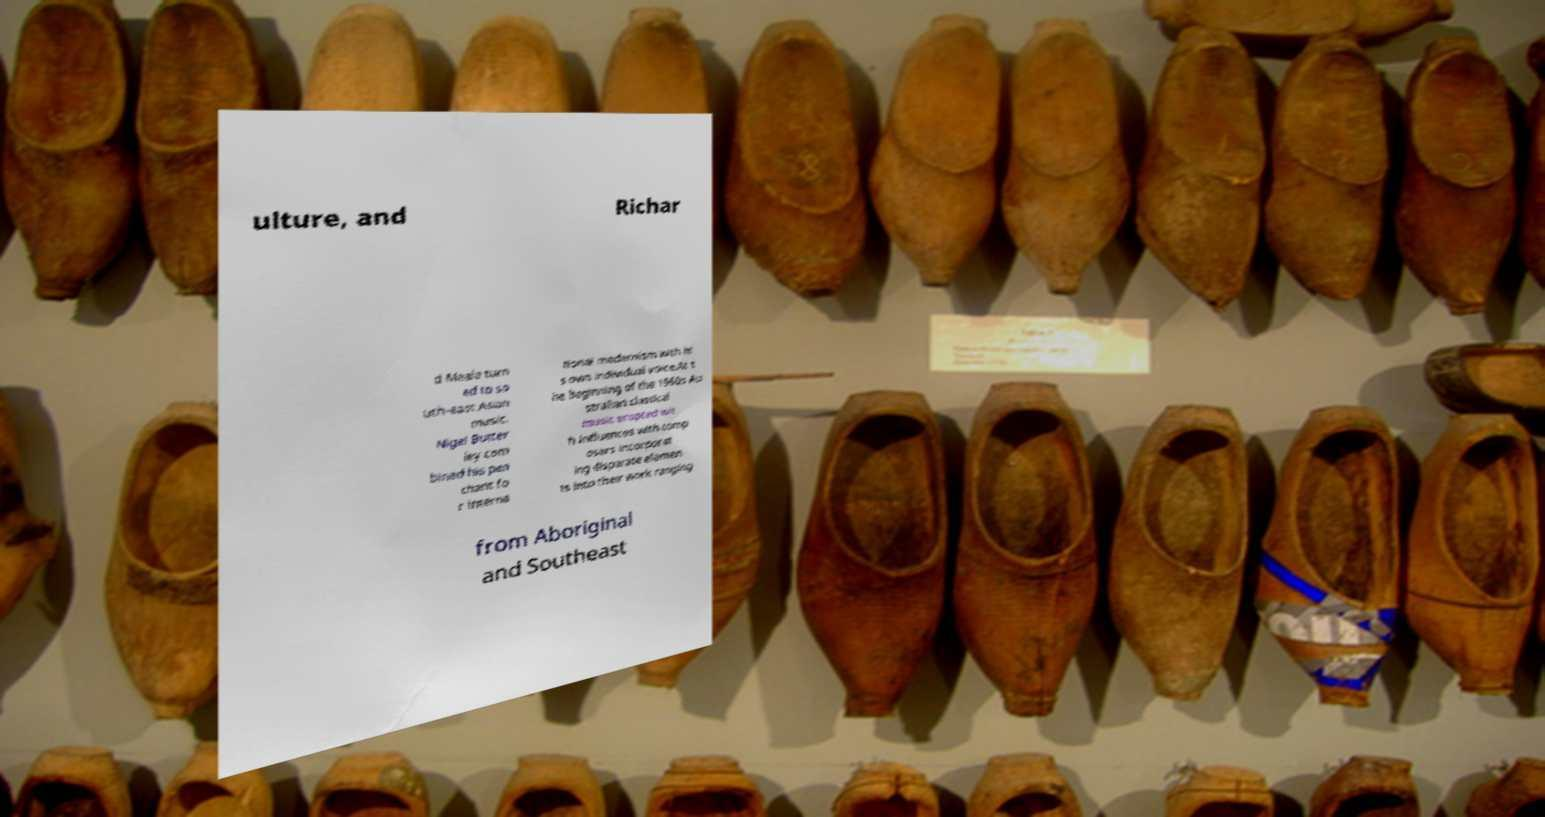Could you assist in decoding the text presented in this image and type it out clearly? ulture, and Richar d Meale turn ed to so uth-east Asian music. Nigel Butter ley com bined his pen chant fo r interna tional modernism with hi s own individual voice.At t he beginning of the 1960s Au stralian classical music erupted wit h influences with comp osers incorporat ing disparate elemen ts into their work ranging from Aboriginal and Southeast 